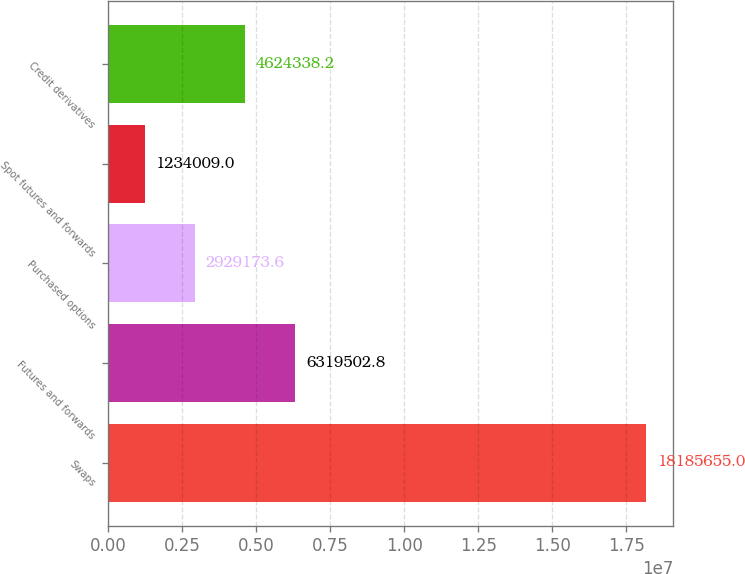<chart> <loc_0><loc_0><loc_500><loc_500><bar_chart><fcel>Swaps<fcel>Futures and forwards<fcel>Purchased options<fcel>Spot futures and forwards<fcel>Credit derivatives<nl><fcel>1.81857e+07<fcel>6.3195e+06<fcel>2.92917e+06<fcel>1.23401e+06<fcel>4.62434e+06<nl></chart> 